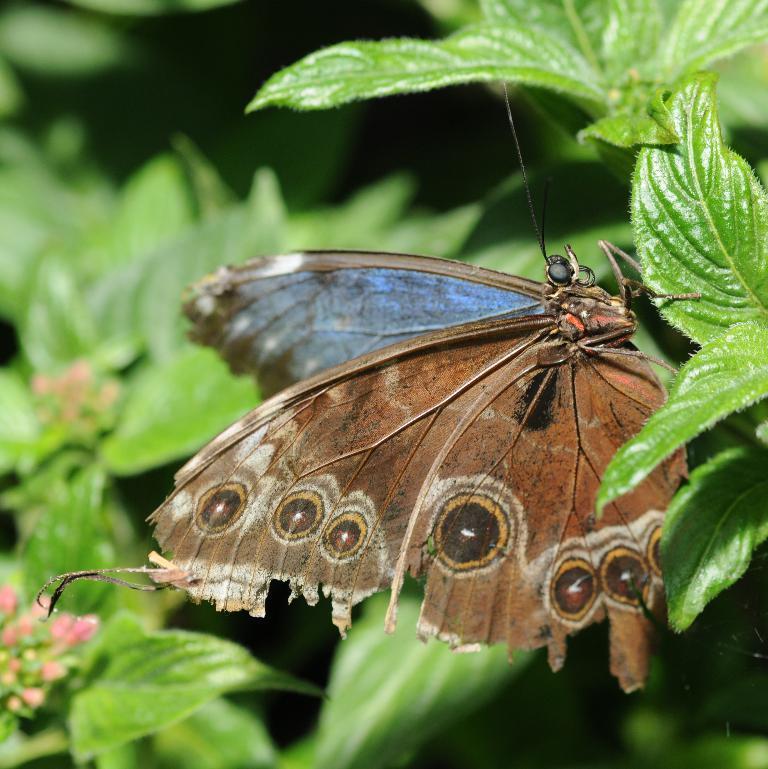Can you describe this image briefly? In this image we can see one butterfly on the leaf, some plants with flowers and buds. 